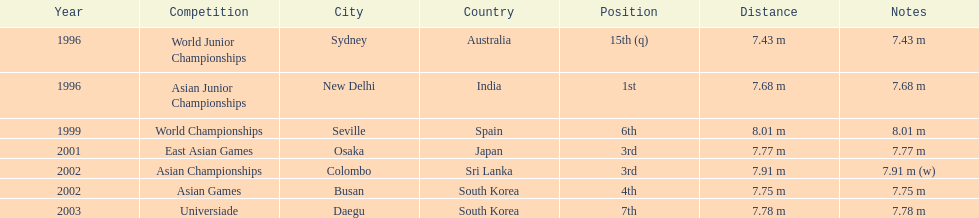Tell me the only venue in spain. Seville, Spain. 